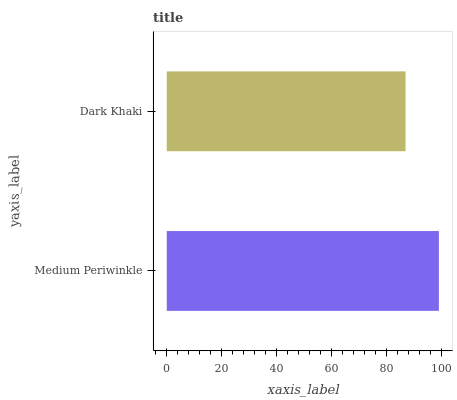Is Dark Khaki the minimum?
Answer yes or no. Yes. Is Medium Periwinkle the maximum?
Answer yes or no. Yes. Is Dark Khaki the maximum?
Answer yes or no. No. Is Medium Periwinkle greater than Dark Khaki?
Answer yes or no. Yes. Is Dark Khaki less than Medium Periwinkle?
Answer yes or no. Yes. Is Dark Khaki greater than Medium Periwinkle?
Answer yes or no. No. Is Medium Periwinkle less than Dark Khaki?
Answer yes or no. No. Is Medium Periwinkle the high median?
Answer yes or no. Yes. Is Dark Khaki the low median?
Answer yes or no. Yes. Is Dark Khaki the high median?
Answer yes or no. No. Is Medium Periwinkle the low median?
Answer yes or no. No. 